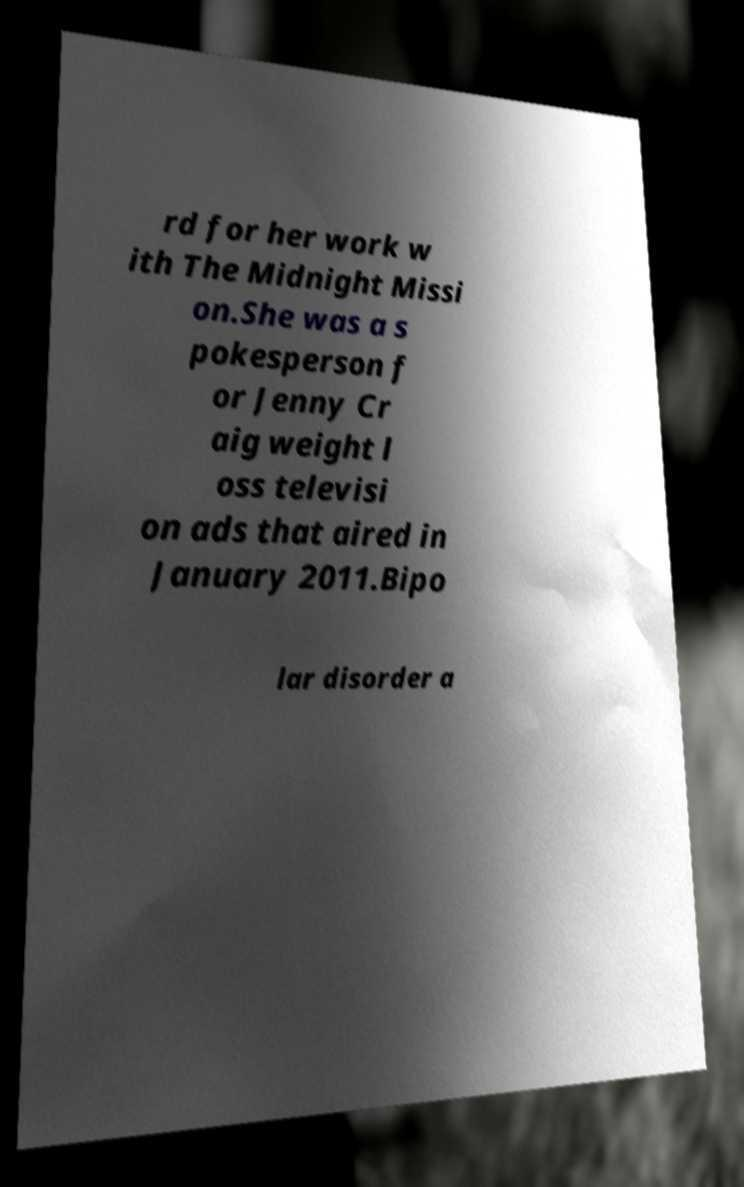Could you extract and type out the text from this image? rd for her work w ith The Midnight Missi on.She was a s pokesperson f or Jenny Cr aig weight l oss televisi on ads that aired in January 2011.Bipo lar disorder a 